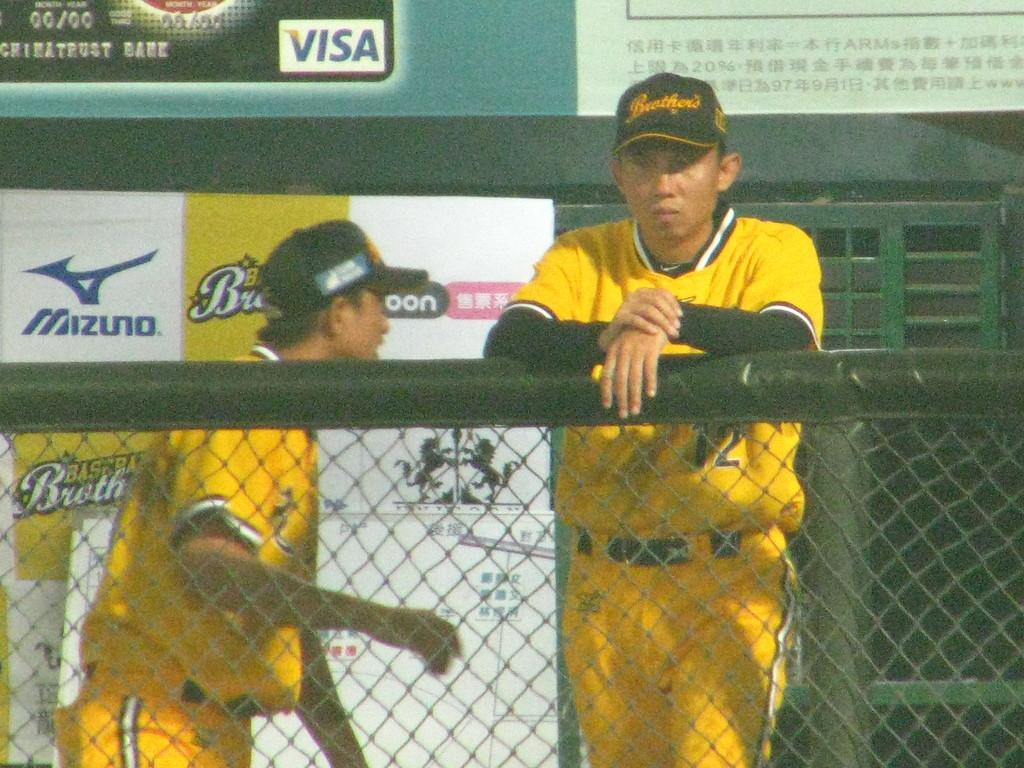How many people are present in the image? There are two men in the image. What is the purpose of the fencing net in the image? The fencing net is likely used for sports or recreational activities. What type of decorations are present in the image? There are posters in the image. Can you describe any other objects in the image? There are some unspecified objects in the image. What color are the eyes of the men in the image? There is no information about the men's eyes in the image, so we cannot determine their color. How much salt is present in the image? There is no salt visible in the image. 